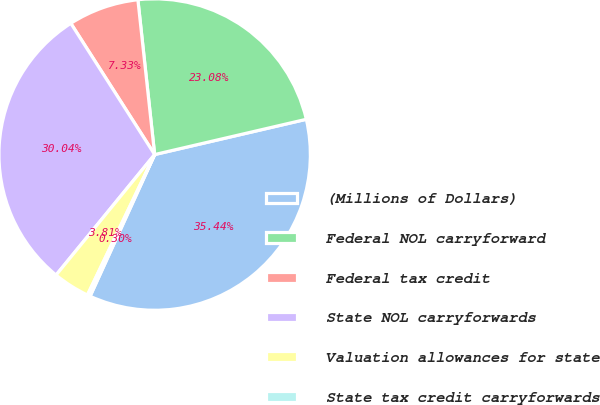<chart> <loc_0><loc_0><loc_500><loc_500><pie_chart><fcel>(Millions of Dollars)<fcel>Federal NOL carryforward<fcel>Federal tax credit<fcel>State NOL carryforwards<fcel>Valuation allowances for state<fcel>State tax credit carryforwards<nl><fcel>35.44%<fcel>23.08%<fcel>7.33%<fcel>30.04%<fcel>3.81%<fcel>0.3%<nl></chart> 